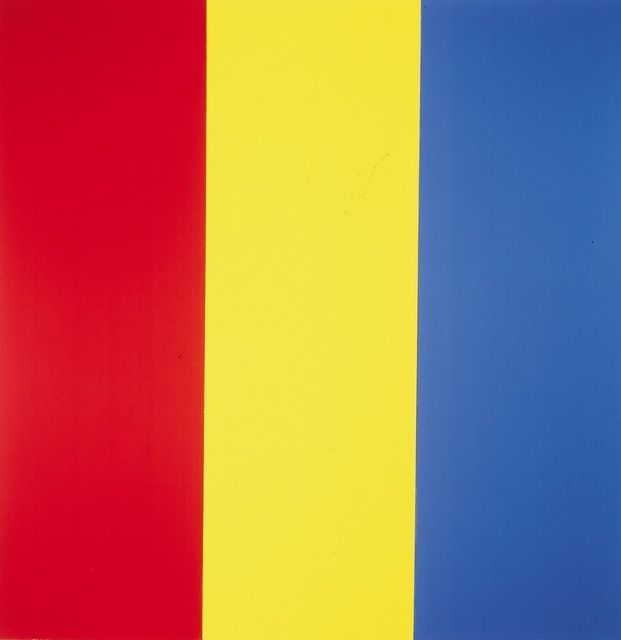Can you elaborate on the cultural or historical significance of this kind of artwork? Color field painting emerged in the mid-20th century as part of the Abstract Expressionist movement. Artists like Mark Rothko, Barnett Newman, and Clyfford Still were among the pioneers. This style sought to move away from the gestural brushstrokes and emotional intensity of earlier abstract art, instead focusing on large fields of color intended to envelop the viewer. These artists aimed to invoke an introspective and immersive experience, where the viewer could connect with the emotional resonance of pure color. The cultural significance lies in its break from traditional forms, encouraging new ways of seeing and experiencing art. How do these colors typically affect the viewer's emotions? Colors can have profound psychological effects. Red is often associated with energy, passion, and sometimes aggression. It can evoke strong emotional reactions and demands attention. Yellow is typically linked with happiness, positivity, and warmth, reminiscent of sunlight. It often brings a sense of cheerfulness and vitality. Blue, on the other hand, is generally calming and serene. It can evoke feelings of tranquility, security, and sometimes sadness. The combination of these colors in equal measure creates a balanced piece that can elicit a wide range of emotional responses from viewers. 